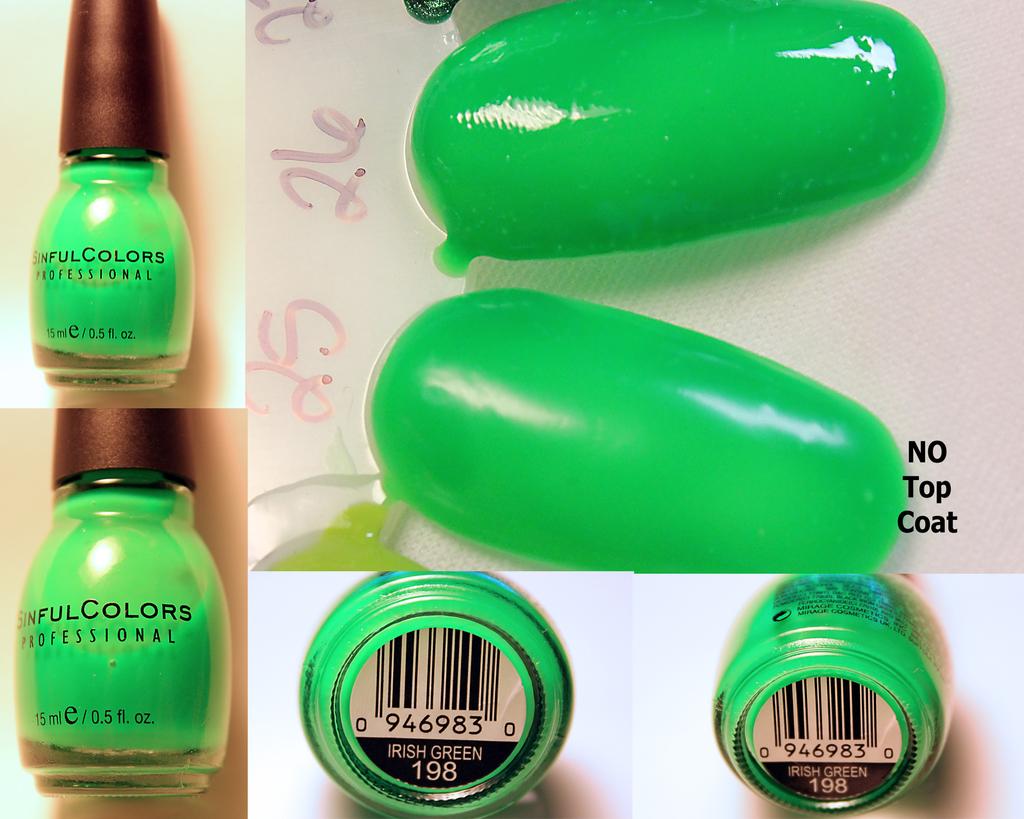What is the name of this color?
Give a very brief answer. Irish green. How many ounces is the container?
Your answer should be very brief. 0.5. 